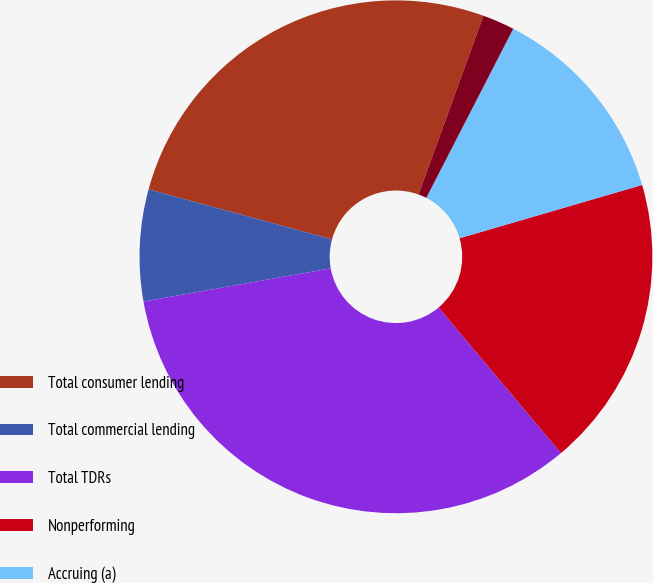Convert chart to OTSL. <chart><loc_0><loc_0><loc_500><loc_500><pie_chart><fcel>Total consumer lending<fcel>Total commercial lending<fcel>Total TDRs<fcel>Nonperforming<fcel>Accruing (a)<fcel>Credit card<nl><fcel>26.3%<fcel>7.03%<fcel>33.33%<fcel>18.39%<fcel>12.92%<fcel>2.02%<nl></chart> 